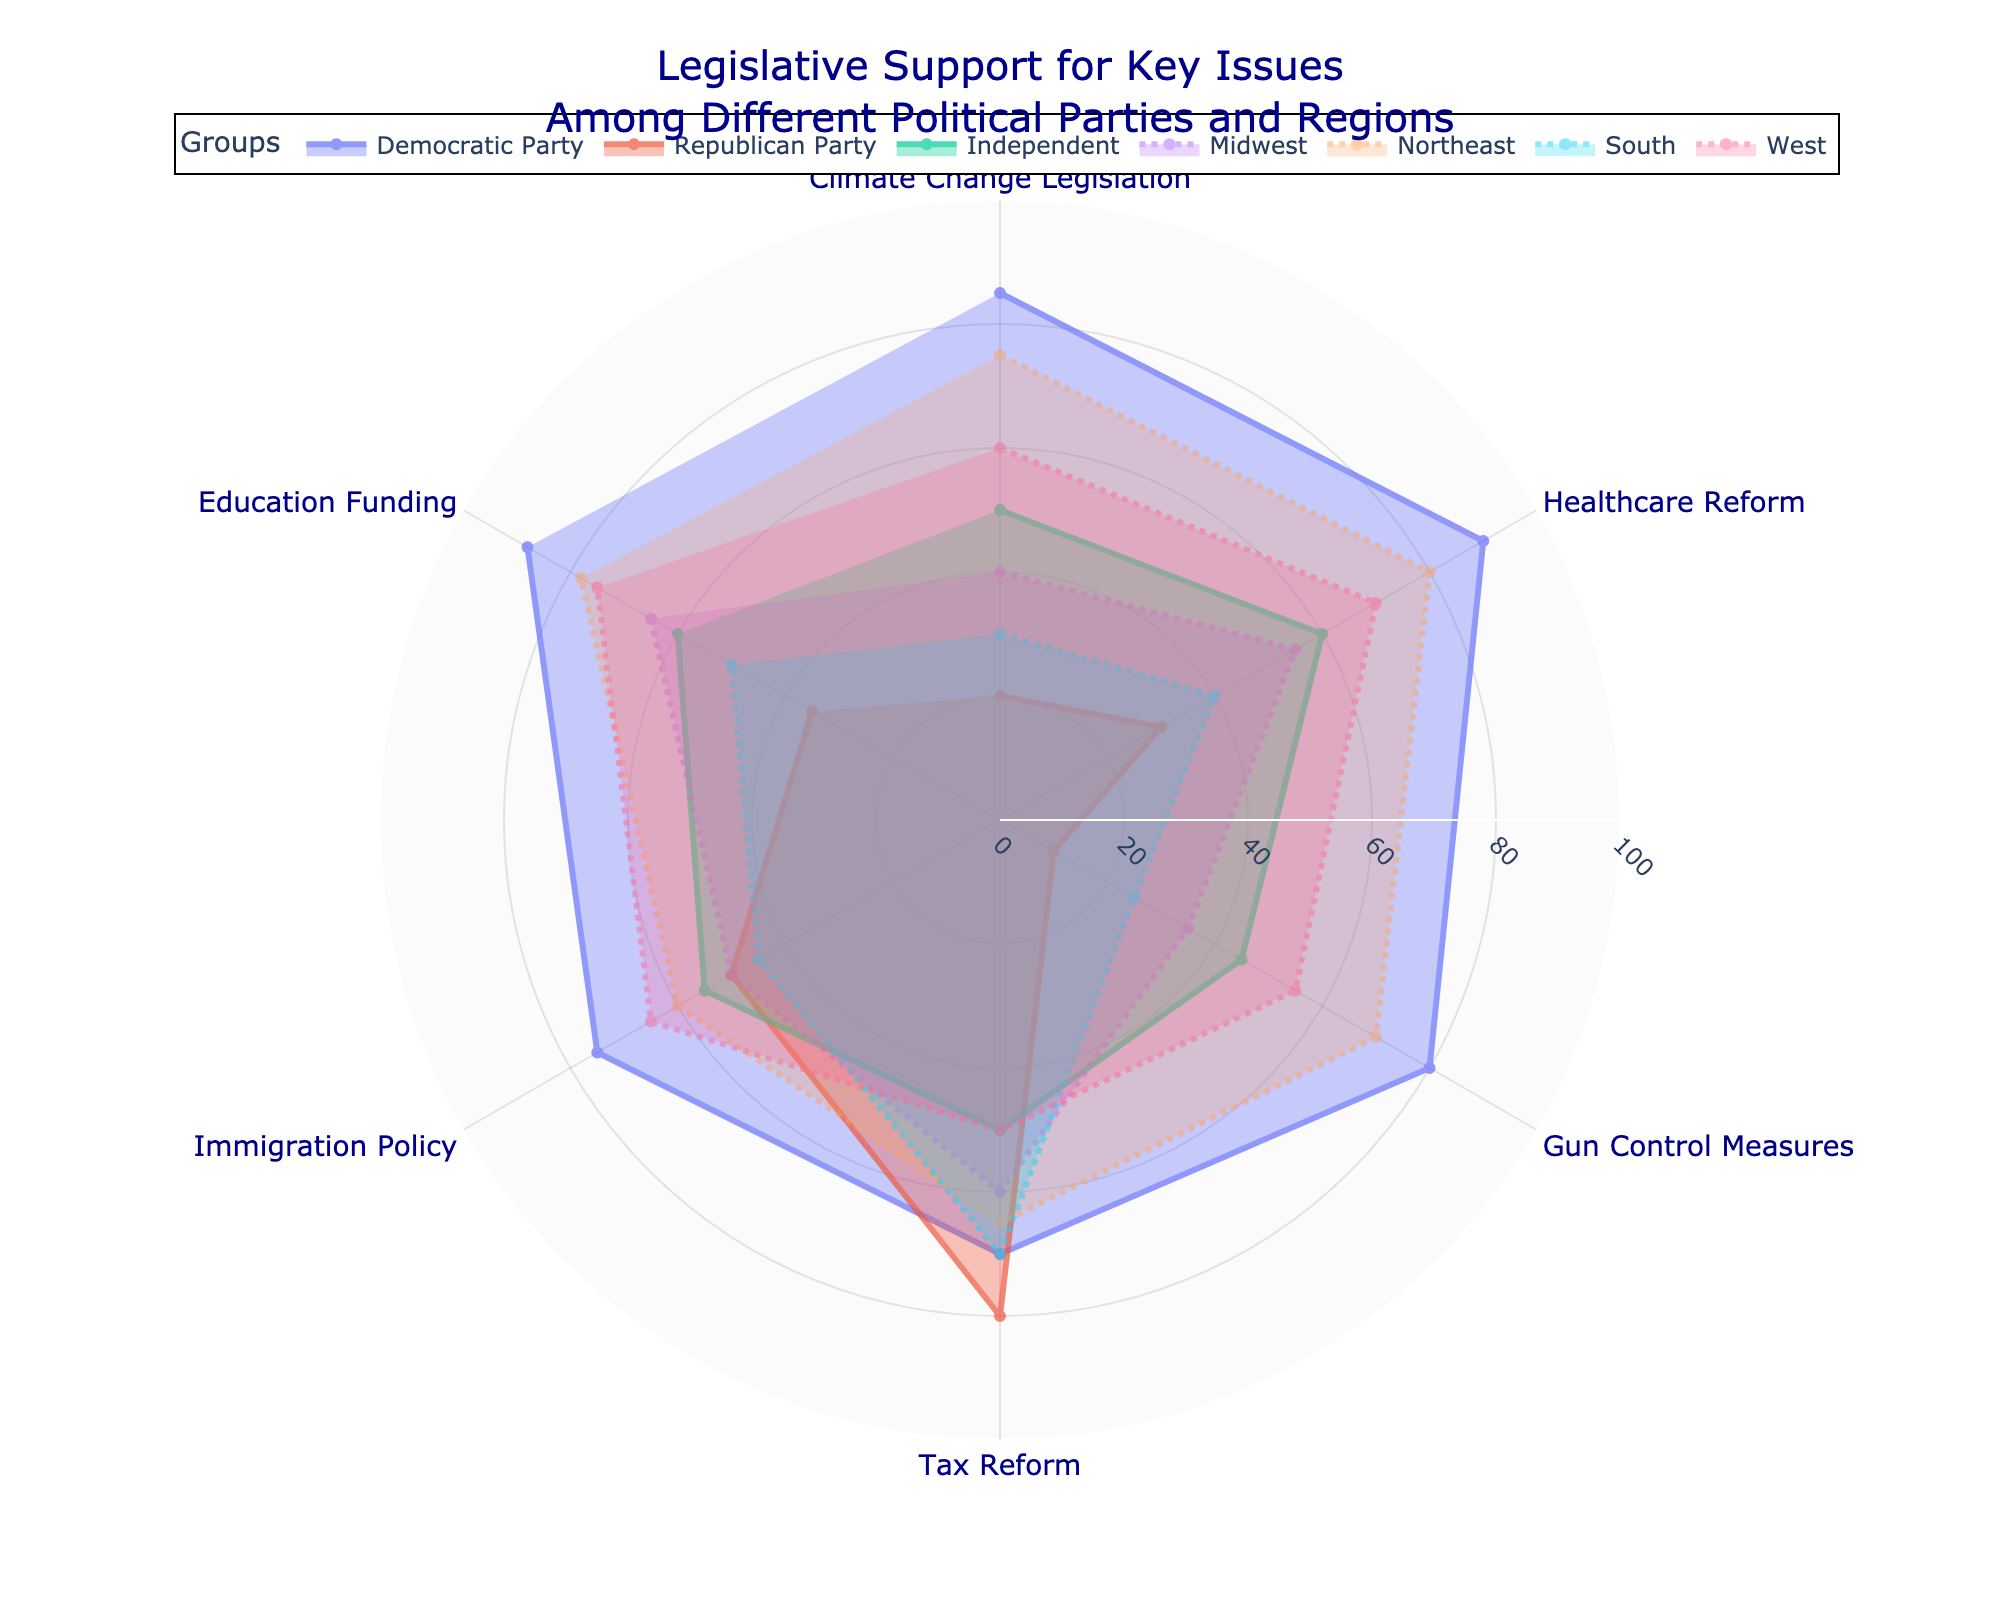Which political party shows the highest support for Climate Change Legislation? To find this, locate the value for "Climate Change Legislation" under each political party. Democratic Party has 85, Republican Party has 20, and Independent has 50. Democratic Party has the highest support.
Answer: Democratic Party What is the lowest support percentage for Healthcare Reform among the regions? Look at the values for "Healthcare Reform" among Midwest, Northeast, South, and West. Midwest has 55, Northeast has 80, South has 40, and West has 70. The lowest support is 40 in the South.
Answer: 40 in the South How does the support for Gun Control Measures compare between the West and the South? Find the values for "Gun Control Measures" in both the West and the South. The West has 55 and the South has 25. The West has higher support by a margin of 30.
Answer: West is higher by 30 Among the political parties, which one shows the least support for Education Funding? Look at "Education Funding" values under each political party. Democratic Party has 88, Republican Party has 35, and Independent has 60. Republican Party shows the least support.
Answer: Republican Party Calculate the average support for Tax Reform among the political parties. Sum the values for "Tax Reform" for Democratic Party (70), Republican Party (80), and Independent (50), which equals 200. Divide by 3 to get the average, 200 / 3 = around 66.7.
Answer: Approximately 66.7 Which issue shows the greatest support difference between the Northeast and South regions? Compare each issue's values between Northeast and South: 
Climate Change Legislation (75 vs 30, difference 45)
Healthcare Reform (80 vs 40, difference 40)
Gun Control Measures (70 vs 25, difference 45)
Tax Reform (65 vs 70, difference 5)
Immigration Policy (60 vs 45, difference 15)
Education Funding (78 vs 50, difference 28).
The issues "Climate Change Legislation" and "Gun Control Measures" both show the greatest difference of 45.
Answer: Climate Change Legislation and Gun Control Measures What is the median support value for Immigration Policy among the regions? For Immigration Policy, the values are Midwest (50), Northeast (60), South (45), and West (65). Sort these values: 45, 50, 60, 65. There are 4 values, so the median is the average of the middle two, (50 + 60) / 2 = 55.
Answer: 55 Compare the support for Healthcare Reform between the Democratic Party and the Northeast region. Which is higher? Democratic Party has 90, and the Northeast has 80 for "Healthcare Reform". Democratic Party's support is higher by a margin of 10.
Answer: Democratic Party is higher by 10 Which issue has the smallest difference in support ranging between all political parties and regions combined? Calculate the range (max - min) for each issue among all parties and regions:
Climate Change Legislation: (85-20, 85-50, ..., max-min is 85-20=65)
Healthcare Reform: (max-min is 90-30=60)
Gun Control Measures: (max-min is 80-10=70)
Tax Reform: (max-min is 80-50=30)
Immigration Policy: (max-min is 75-45=30)
Education Funding: (max-min is 88-35=53)
The issues "Tax Reform" and "Immigration Policy" both have the smallest range of 30.
Answer: Tax Reform and Immigration Policy 